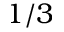Convert formula to latex. <formula><loc_0><loc_0><loc_500><loc_500>1 / 3</formula> 